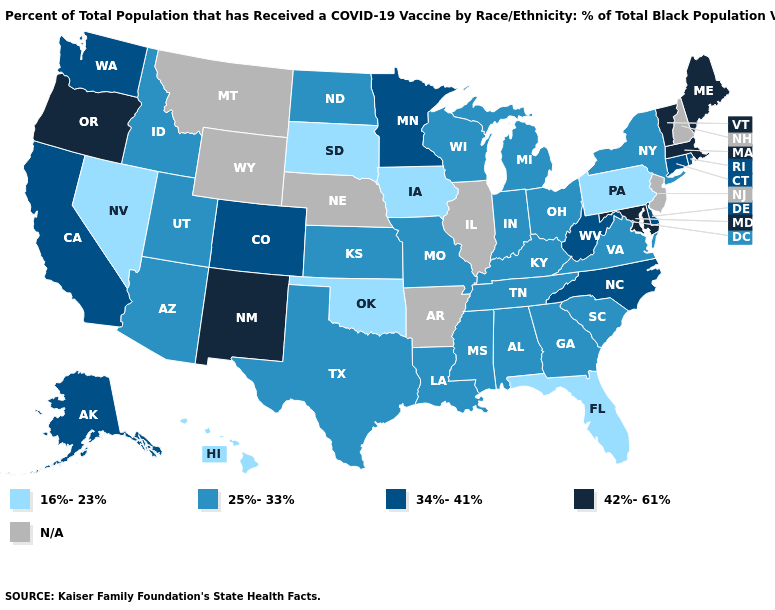Does Massachusetts have the highest value in the Northeast?
Answer briefly. Yes. What is the value of Montana?
Be succinct. N/A. Name the states that have a value in the range 42%-61%?
Give a very brief answer. Maine, Maryland, Massachusetts, New Mexico, Oregon, Vermont. What is the value of Oklahoma?
Give a very brief answer. 16%-23%. Name the states that have a value in the range 34%-41%?
Quick response, please. Alaska, California, Colorado, Connecticut, Delaware, Minnesota, North Carolina, Rhode Island, Washington, West Virginia. Name the states that have a value in the range 25%-33%?
Concise answer only. Alabama, Arizona, Georgia, Idaho, Indiana, Kansas, Kentucky, Louisiana, Michigan, Mississippi, Missouri, New York, North Dakota, Ohio, South Carolina, Tennessee, Texas, Utah, Virginia, Wisconsin. Name the states that have a value in the range 16%-23%?
Answer briefly. Florida, Hawaii, Iowa, Nevada, Oklahoma, Pennsylvania, South Dakota. Name the states that have a value in the range 25%-33%?
Concise answer only. Alabama, Arizona, Georgia, Idaho, Indiana, Kansas, Kentucky, Louisiana, Michigan, Mississippi, Missouri, New York, North Dakota, Ohio, South Carolina, Tennessee, Texas, Utah, Virginia, Wisconsin. Which states have the highest value in the USA?
Short answer required. Maine, Maryland, Massachusetts, New Mexico, Oregon, Vermont. What is the value of Tennessee?
Quick response, please. 25%-33%. Does Massachusetts have the highest value in the USA?
Give a very brief answer. Yes. What is the highest value in the USA?
Answer briefly. 42%-61%. Is the legend a continuous bar?
Short answer required. No. What is the value of South Carolina?
Give a very brief answer. 25%-33%. 